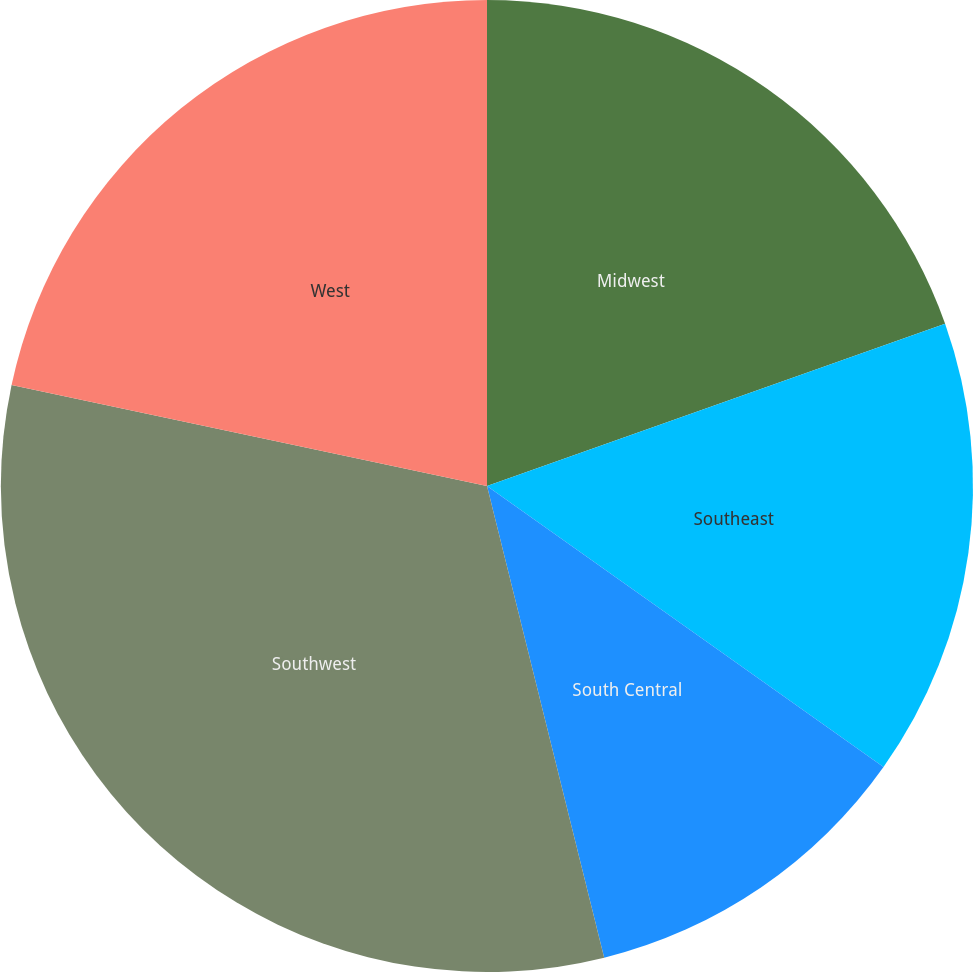Convert chart. <chart><loc_0><loc_0><loc_500><loc_500><pie_chart><fcel>Midwest<fcel>Southeast<fcel>South Central<fcel>Southwest<fcel>West<nl><fcel>19.58%<fcel>15.23%<fcel>11.31%<fcel>32.2%<fcel>21.67%<nl></chart> 